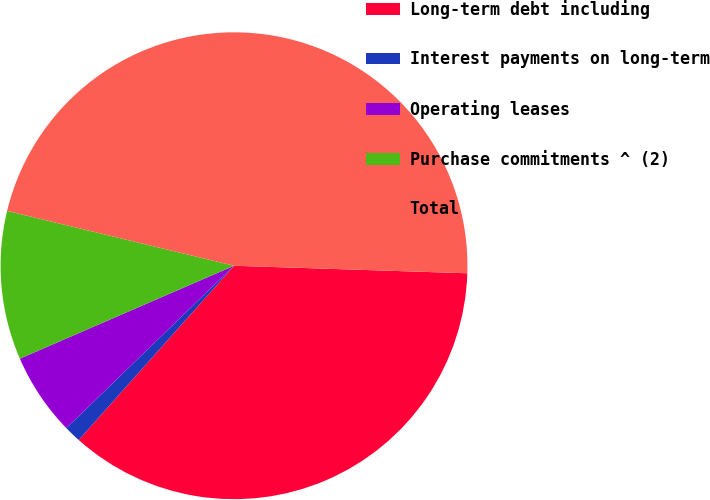<chart> <loc_0><loc_0><loc_500><loc_500><pie_chart><fcel>Long-term debt including<fcel>Interest payments on long-term<fcel>Operating leases<fcel>Purchase commitments ^ (2)<fcel>Total<nl><fcel>36.07%<fcel>1.17%<fcel>5.73%<fcel>10.29%<fcel>46.74%<nl></chart> 